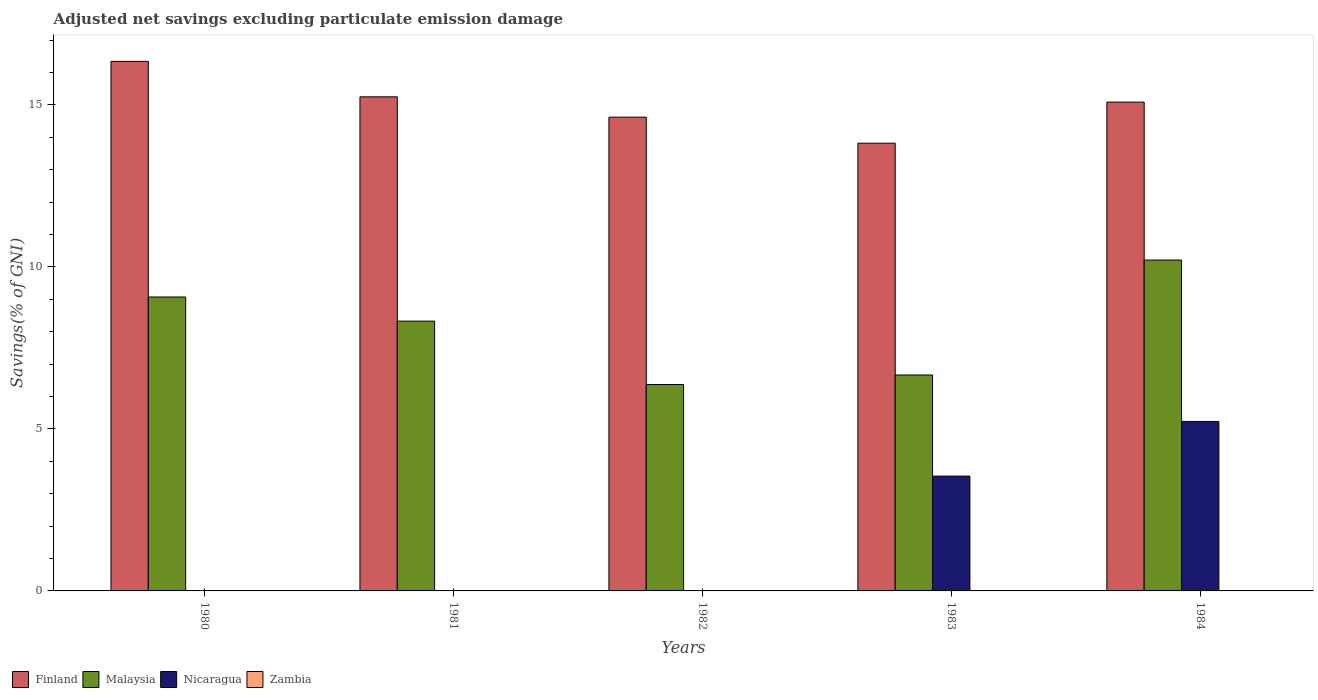How many different coloured bars are there?
Your answer should be compact. 3. Are the number of bars on each tick of the X-axis equal?
Ensure brevity in your answer.  No. How many bars are there on the 4th tick from the left?
Offer a very short reply. 3. How many bars are there on the 3rd tick from the right?
Your response must be concise. 2. What is the adjusted net savings in Nicaragua in 1984?
Offer a very short reply. 5.23. Across all years, what is the maximum adjusted net savings in Finland?
Your answer should be compact. 16.34. Across all years, what is the minimum adjusted net savings in Malaysia?
Offer a terse response. 6.37. What is the total adjusted net savings in Finland in the graph?
Provide a short and direct response. 75.12. What is the difference between the adjusted net savings in Malaysia in 1981 and that in 1984?
Provide a succinct answer. -1.89. What is the difference between the adjusted net savings in Finland in 1981 and the adjusted net savings in Nicaragua in 1984?
Provide a short and direct response. 10.02. What is the average adjusted net savings in Malaysia per year?
Ensure brevity in your answer.  8.13. In the year 1983, what is the difference between the adjusted net savings in Nicaragua and adjusted net savings in Malaysia?
Provide a short and direct response. -3.12. In how many years, is the adjusted net savings in Nicaragua greater than 11 %?
Offer a very short reply. 0. What is the ratio of the adjusted net savings in Malaysia in 1980 to that in 1983?
Offer a very short reply. 1.36. Is the adjusted net savings in Malaysia in 1980 less than that in 1984?
Your answer should be compact. Yes. What is the difference between the highest and the second highest adjusted net savings in Malaysia?
Your response must be concise. 1.14. What is the difference between the highest and the lowest adjusted net savings in Finland?
Make the answer very short. 2.53. In how many years, is the adjusted net savings in Zambia greater than the average adjusted net savings in Zambia taken over all years?
Offer a very short reply. 0. Is it the case that in every year, the sum of the adjusted net savings in Nicaragua and adjusted net savings in Malaysia is greater than the sum of adjusted net savings in Finland and adjusted net savings in Zambia?
Your answer should be very brief. No. Is it the case that in every year, the sum of the adjusted net savings in Finland and adjusted net savings in Malaysia is greater than the adjusted net savings in Nicaragua?
Offer a terse response. Yes. How many bars are there?
Your answer should be very brief. 12. Are all the bars in the graph horizontal?
Offer a very short reply. No. How many years are there in the graph?
Offer a terse response. 5. Does the graph contain any zero values?
Offer a terse response. Yes. Where does the legend appear in the graph?
Give a very brief answer. Bottom left. How many legend labels are there?
Your response must be concise. 4. How are the legend labels stacked?
Keep it short and to the point. Horizontal. What is the title of the graph?
Offer a very short reply. Adjusted net savings excluding particulate emission damage. Does "Yemen, Rep." appear as one of the legend labels in the graph?
Provide a succinct answer. No. What is the label or title of the Y-axis?
Keep it short and to the point. Savings(% of GNI). What is the Savings(% of GNI) of Finland in 1980?
Keep it short and to the point. 16.34. What is the Savings(% of GNI) of Malaysia in 1980?
Keep it short and to the point. 9.07. What is the Savings(% of GNI) in Zambia in 1980?
Your answer should be compact. 0. What is the Savings(% of GNI) in Finland in 1981?
Offer a very short reply. 15.25. What is the Savings(% of GNI) in Malaysia in 1981?
Make the answer very short. 8.33. What is the Savings(% of GNI) of Nicaragua in 1981?
Your answer should be very brief. 0. What is the Savings(% of GNI) in Zambia in 1981?
Your answer should be very brief. 0. What is the Savings(% of GNI) of Finland in 1982?
Provide a short and direct response. 14.62. What is the Savings(% of GNI) of Malaysia in 1982?
Provide a succinct answer. 6.37. What is the Savings(% of GNI) in Nicaragua in 1982?
Give a very brief answer. 0. What is the Savings(% of GNI) in Finland in 1983?
Give a very brief answer. 13.82. What is the Savings(% of GNI) in Malaysia in 1983?
Offer a very short reply. 6.66. What is the Savings(% of GNI) of Nicaragua in 1983?
Keep it short and to the point. 3.54. What is the Savings(% of GNI) in Zambia in 1983?
Your answer should be compact. 0. What is the Savings(% of GNI) of Finland in 1984?
Give a very brief answer. 15.09. What is the Savings(% of GNI) of Malaysia in 1984?
Your response must be concise. 10.21. What is the Savings(% of GNI) in Nicaragua in 1984?
Give a very brief answer. 5.23. Across all years, what is the maximum Savings(% of GNI) of Finland?
Keep it short and to the point. 16.34. Across all years, what is the maximum Savings(% of GNI) of Malaysia?
Ensure brevity in your answer.  10.21. Across all years, what is the maximum Savings(% of GNI) in Nicaragua?
Offer a terse response. 5.23. Across all years, what is the minimum Savings(% of GNI) in Finland?
Make the answer very short. 13.82. Across all years, what is the minimum Savings(% of GNI) in Malaysia?
Your answer should be compact. 6.37. What is the total Savings(% of GNI) in Finland in the graph?
Ensure brevity in your answer.  75.12. What is the total Savings(% of GNI) in Malaysia in the graph?
Provide a succinct answer. 40.64. What is the total Savings(% of GNI) in Nicaragua in the graph?
Give a very brief answer. 8.78. What is the total Savings(% of GNI) in Zambia in the graph?
Offer a very short reply. 0. What is the difference between the Savings(% of GNI) of Finland in 1980 and that in 1981?
Provide a short and direct response. 1.09. What is the difference between the Savings(% of GNI) in Malaysia in 1980 and that in 1981?
Your answer should be very brief. 0.74. What is the difference between the Savings(% of GNI) in Finland in 1980 and that in 1982?
Provide a succinct answer. 1.72. What is the difference between the Savings(% of GNI) of Malaysia in 1980 and that in 1982?
Provide a succinct answer. 2.7. What is the difference between the Savings(% of GNI) in Finland in 1980 and that in 1983?
Provide a short and direct response. 2.53. What is the difference between the Savings(% of GNI) of Malaysia in 1980 and that in 1983?
Your answer should be very brief. 2.41. What is the difference between the Savings(% of GNI) of Finland in 1980 and that in 1984?
Offer a very short reply. 1.26. What is the difference between the Savings(% of GNI) in Malaysia in 1980 and that in 1984?
Provide a succinct answer. -1.14. What is the difference between the Savings(% of GNI) in Finland in 1981 and that in 1982?
Provide a succinct answer. 0.63. What is the difference between the Savings(% of GNI) of Malaysia in 1981 and that in 1982?
Ensure brevity in your answer.  1.96. What is the difference between the Savings(% of GNI) of Finland in 1981 and that in 1983?
Your answer should be compact. 1.43. What is the difference between the Savings(% of GNI) of Malaysia in 1981 and that in 1983?
Give a very brief answer. 1.66. What is the difference between the Savings(% of GNI) of Finland in 1981 and that in 1984?
Ensure brevity in your answer.  0.16. What is the difference between the Savings(% of GNI) of Malaysia in 1981 and that in 1984?
Offer a terse response. -1.89. What is the difference between the Savings(% of GNI) in Finland in 1982 and that in 1983?
Offer a terse response. 0.8. What is the difference between the Savings(% of GNI) in Malaysia in 1982 and that in 1983?
Your answer should be compact. -0.3. What is the difference between the Savings(% of GNI) in Finland in 1982 and that in 1984?
Provide a succinct answer. -0.46. What is the difference between the Savings(% of GNI) in Malaysia in 1982 and that in 1984?
Your answer should be very brief. -3.84. What is the difference between the Savings(% of GNI) of Finland in 1983 and that in 1984?
Make the answer very short. -1.27. What is the difference between the Savings(% of GNI) of Malaysia in 1983 and that in 1984?
Give a very brief answer. -3.55. What is the difference between the Savings(% of GNI) of Nicaragua in 1983 and that in 1984?
Your response must be concise. -1.69. What is the difference between the Savings(% of GNI) in Finland in 1980 and the Savings(% of GNI) in Malaysia in 1981?
Give a very brief answer. 8.02. What is the difference between the Savings(% of GNI) in Finland in 1980 and the Savings(% of GNI) in Malaysia in 1982?
Your answer should be very brief. 9.97. What is the difference between the Savings(% of GNI) of Finland in 1980 and the Savings(% of GNI) of Malaysia in 1983?
Your answer should be compact. 9.68. What is the difference between the Savings(% of GNI) in Finland in 1980 and the Savings(% of GNI) in Nicaragua in 1983?
Offer a very short reply. 12.8. What is the difference between the Savings(% of GNI) of Malaysia in 1980 and the Savings(% of GNI) of Nicaragua in 1983?
Offer a very short reply. 5.53. What is the difference between the Savings(% of GNI) in Finland in 1980 and the Savings(% of GNI) in Malaysia in 1984?
Your answer should be very brief. 6.13. What is the difference between the Savings(% of GNI) of Finland in 1980 and the Savings(% of GNI) of Nicaragua in 1984?
Keep it short and to the point. 11.11. What is the difference between the Savings(% of GNI) of Malaysia in 1980 and the Savings(% of GNI) of Nicaragua in 1984?
Ensure brevity in your answer.  3.84. What is the difference between the Savings(% of GNI) in Finland in 1981 and the Savings(% of GNI) in Malaysia in 1982?
Offer a terse response. 8.88. What is the difference between the Savings(% of GNI) in Finland in 1981 and the Savings(% of GNI) in Malaysia in 1983?
Your response must be concise. 8.58. What is the difference between the Savings(% of GNI) in Finland in 1981 and the Savings(% of GNI) in Nicaragua in 1983?
Ensure brevity in your answer.  11.7. What is the difference between the Savings(% of GNI) of Malaysia in 1981 and the Savings(% of GNI) of Nicaragua in 1983?
Offer a very short reply. 4.78. What is the difference between the Savings(% of GNI) of Finland in 1981 and the Savings(% of GNI) of Malaysia in 1984?
Provide a succinct answer. 5.04. What is the difference between the Savings(% of GNI) in Finland in 1981 and the Savings(% of GNI) in Nicaragua in 1984?
Provide a short and direct response. 10.02. What is the difference between the Savings(% of GNI) of Malaysia in 1981 and the Savings(% of GNI) of Nicaragua in 1984?
Offer a very short reply. 3.1. What is the difference between the Savings(% of GNI) in Finland in 1982 and the Savings(% of GNI) in Malaysia in 1983?
Your answer should be very brief. 7.96. What is the difference between the Savings(% of GNI) in Finland in 1982 and the Savings(% of GNI) in Nicaragua in 1983?
Provide a succinct answer. 11.08. What is the difference between the Savings(% of GNI) of Malaysia in 1982 and the Savings(% of GNI) of Nicaragua in 1983?
Your response must be concise. 2.83. What is the difference between the Savings(% of GNI) in Finland in 1982 and the Savings(% of GNI) in Malaysia in 1984?
Your response must be concise. 4.41. What is the difference between the Savings(% of GNI) of Finland in 1982 and the Savings(% of GNI) of Nicaragua in 1984?
Provide a succinct answer. 9.39. What is the difference between the Savings(% of GNI) of Malaysia in 1982 and the Savings(% of GNI) of Nicaragua in 1984?
Your answer should be very brief. 1.14. What is the difference between the Savings(% of GNI) of Finland in 1983 and the Savings(% of GNI) of Malaysia in 1984?
Provide a succinct answer. 3.61. What is the difference between the Savings(% of GNI) in Finland in 1983 and the Savings(% of GNI) in Nicaragua in 1984?
Make the answer very short. 8.59. What is the difference between the Savings(% of GNI) in Malaysia in 1983 and the Savings(% of GNI) in Nicaragua in 1984?
Your response must be concise. 1.43. What is the average Savings(% of GNI) in Finland per year?
Your answer should be very brief. 15.02. What is the average Savings(% of GNI) of Malaysia per year?
Provide a succinct answer. 8.13. What is the average Savings(% of GNI) in Nicaragua per year?
Make the answer very short. 1.75. What is the average Savings(% of GNI) in Zambia per year?
Your answer should be very brief. 0. In the year 1980, what is the difference between the Savings(% of GNI) of Finland and Savings(% of GNI) of Malaysia?
Ensure brevity in your answer.  7.27. In the year 1981, what is the difference between the Savings(% of GNI) of Finland and Savings(% of GNI) of Malaysia?
Provide a succinct answer. 6.92. In the year 1982, what is the difference between the Savings(% of GNI) of Finland and Savings(% of GNI) of Malaysia?
Keep it short and to the point. 8.25. In the year 1983, what is the difference between the Savings(% of GNI) of Finland and Savings(% of GNI) of Malaysia?
Your answer should be compact. 7.15. In the year 1983, what is the difference between the Savings(% of GNI) in Finland and Savings(% of GNI) in Nicaragua?
Offer a terse response. 10.27. In the year 1983, what is the difference between the Savings(% of GNI) in Malaysia and Savings(% of GNI) in Nicaragua?
Your answer should be compact. 3.12. In the year 1984, what is the difference between the Savings(% of GNI) in Finland and Savings(% of GNI) in Malaysia?
Make the answer very short. 4.87. In the year 1984, what is the difference between the Savings(% of GNI) of Finland and Savings(% of GNI) of Nicaragua?
Offer a very short reply. 9.85. In the year 1984, what is the difference between the Savings(% of GNI) of Malaysia and Savings(% of GNI) of Nicaragua?
Keep it short and to the point. 4.98. What is the ratio of the Savings(% of GNI) in Finland in 1980 to that in 1981?
Ensure brevity in your answer.  1.07. What is the ratio of the Savings(% of GNI) of Malaysia in 1980 to that in 1981?
Your answer should be very brief. 1.09. What is the ratio of the Savings(% of GNI) in Finland in 1980 to that in 1982?
Keep it short and to the point. 1.12. What is the ratio of the Savings(% of GNI) of Malaysia in 1980 to that in 1982?
Make the answer very short. 1.42. What is the ratio of the Savings(% of GNI) of Finland in 1980 to that in 1983?
Make the answer very short. 1.18. What is the ratio of the Savings(% of GNI) in Malaysia in 1980 to that in 1983?
Keep it short and to the point. 1.36. What is the ratio of the Savings(% of GNI) in Finland in 1980 to that in 1984?
Keep it short and to the point. 1.08. What is the ratio of the Savings(% of GNI) in Malaysia in 1980 to that in 1984?
Keep it short and to the point. 0.89. What is the ratio of the Savings(% of GNI) of Finland in 1981 to that in 1982?
Provide a short and direct response. 1.04. What is the ratio of the Savings(% of GNI) of Malaysia in 1981 to that in 1982?
Provide a short and direct response. 1.31. What is the ratio of the Savings(% of GNI) of Finland in 1981 to that in 1983?
Your answer should be very brief. 1.1. What is the ratio of the Savings(% of GNI) of Malaysia in 1981 to that in 1983?
Your answer should be compact. 1.25. What is the ratio of the Savings(% of GNI) of Finland in 1981 to that in 1984?
Offer a terse response. 1.01. What is the ratio of the Savings(% of GNI) in Malaysia in 1981 to that in 1984?
Make the answer very short. 0.82. What is the ratio of the Savings(% of GNI) of Finland in 1982 to that in 1983?
Offer a terse response. 1.06. What is the ratio of the Savings(% of GNI) of Malaysia in 1982 to that in 1983?
Provide a short and direct response. 0.96. What is the ratio of the Savings(% of GNI) of Finland in 1982 to that in 1984?
Offer a terse response. 0.97. What is the ratio of the Savings(% of GNI) in Malaysia in 1982 to that in 1984?
Ensure brevity in your answer.  0.62. What is the ratio of the Savings(% of GNI) of Finland in 1983 to that in 1984?
Offer a terse response. 0.92. What is the ratio of the Savings(% of GNI) in Malaysia in 1983 to that in 1984?
Ensure brevity in your answer.  0.65. What is the ratio of the Savings(% of GNI) in Nicaragua in 1983 to that in 1984?
Keep it short and to the point. 0.68. What is the difference between the highest and the second highest Savings(% of GNI) of Finland?
Keep it short and to the point. 1.09. What is the difference between the highest and the second highest Savings(% of GNI) in Malaysia?
Give a very brief answer. 1.14. What is the difference between the highest and the lowest Savings(% of GNI) of Finland?
Your answer should be compact. 2.53. What is the difference between the highest and the lowest Savings(% of GNI) of Malaysia?
Provide a short and direct response. 3.84. What is the difference between the highest and the lowest Savings(% of GNI) of Nicaragua?
Provide a short and direct response. 5.23. 